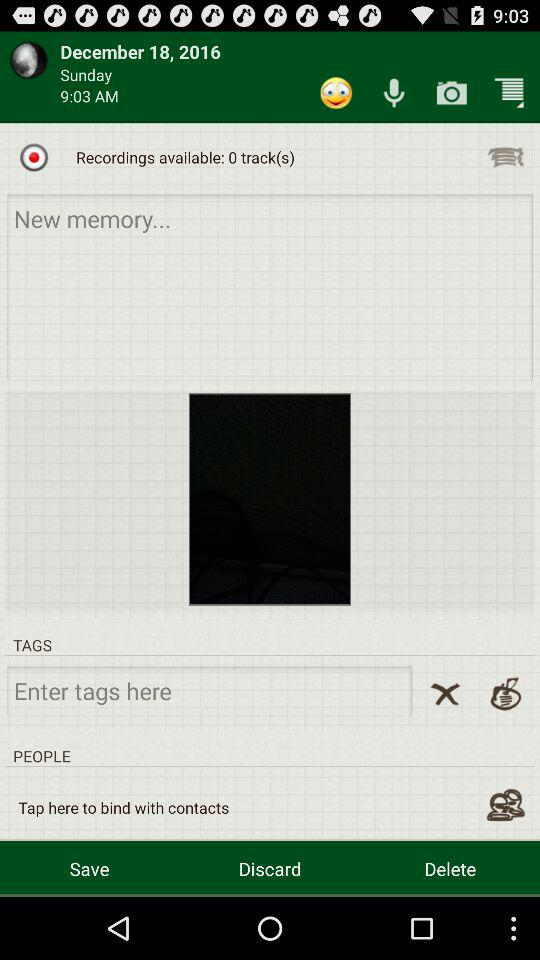What is the date of recording? The date of recording is December 18, 2016. 